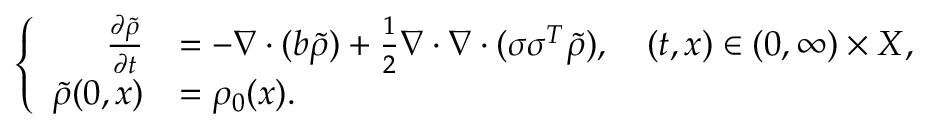<formula> <loc_0><loc_0><loc_500><loc_500>\left \{ \begin{array} { r l } { \frac { \partial \widetilde { \rho } } { \partial t } } & { = - \nabla \cdot ( b \widetilde { \rho } ) + \frac { 1 } { 2 } \nabla \cdot \nabla \cdot ( \sigma \sigma ^ { T } \widetilde { \rho } ) , \quad ( t , x ) \in ( 0 , \infty ) \times X , } \\ { \widetilde { \rho } ( 0 , x ) } & { = \rho _ { 0 } ( x ) . } \end{array}</formula> 